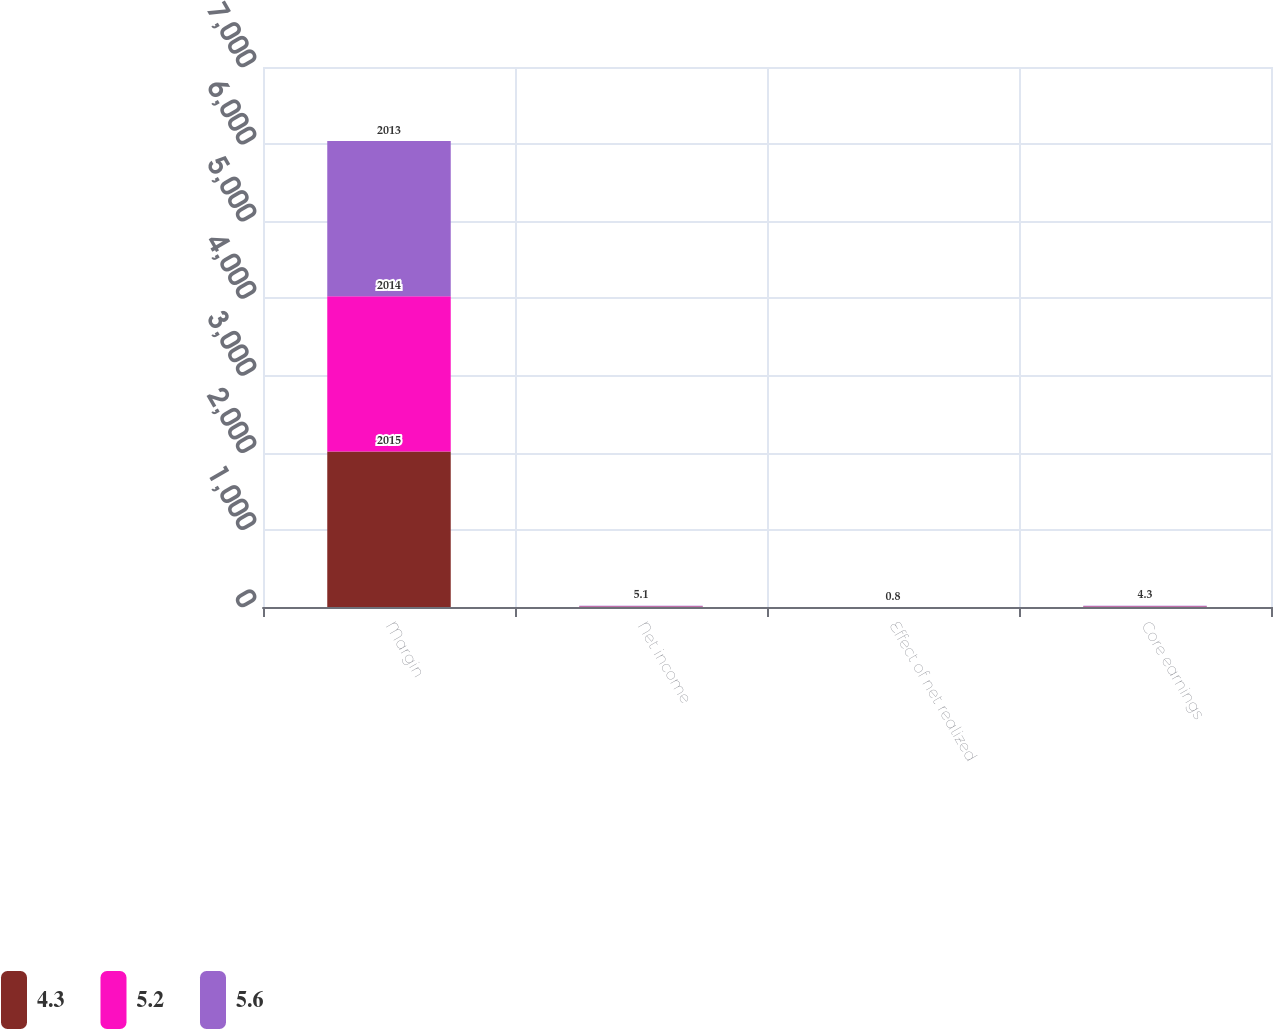Convert chart. <chart><loc_0><loc_0><loc_500><loc_500><stacked_bar_chart><ecel><fcel>Margin<fcel>Net income<fcel>Effect of net realized<fcel>Core earnings<nl><fcel>4.3<fcel>2015<fcel>5.4<fcel>0.2<fcel>5.6<nl><fcel>5.2<fcel>2014<fcel>5.5<fcel>0.3<fcel>5.2<nl><fcel>5.6<fcel>2013<fcel>5.1<fcel>0.8<fcel>4.3<nl></chart> 